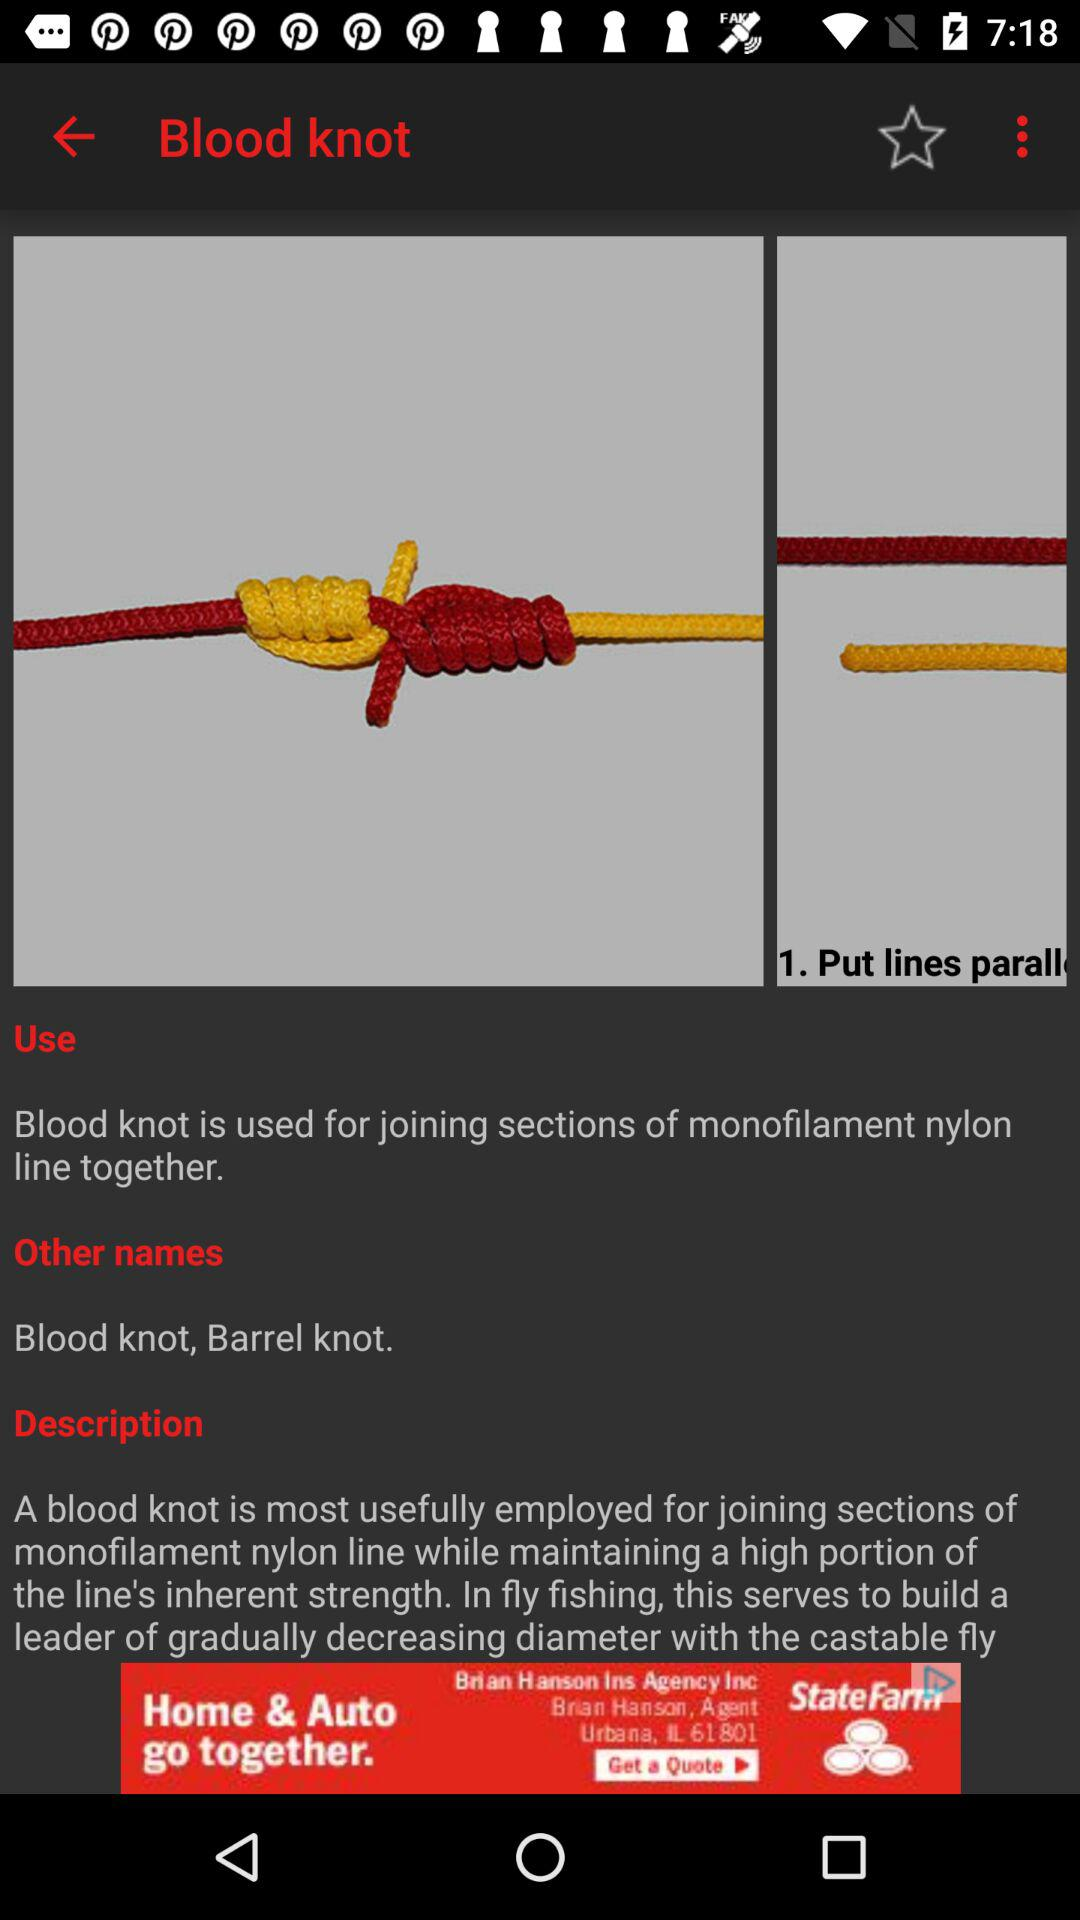What are the other names? The other names are "Blood knot" and "Barrel knot". 